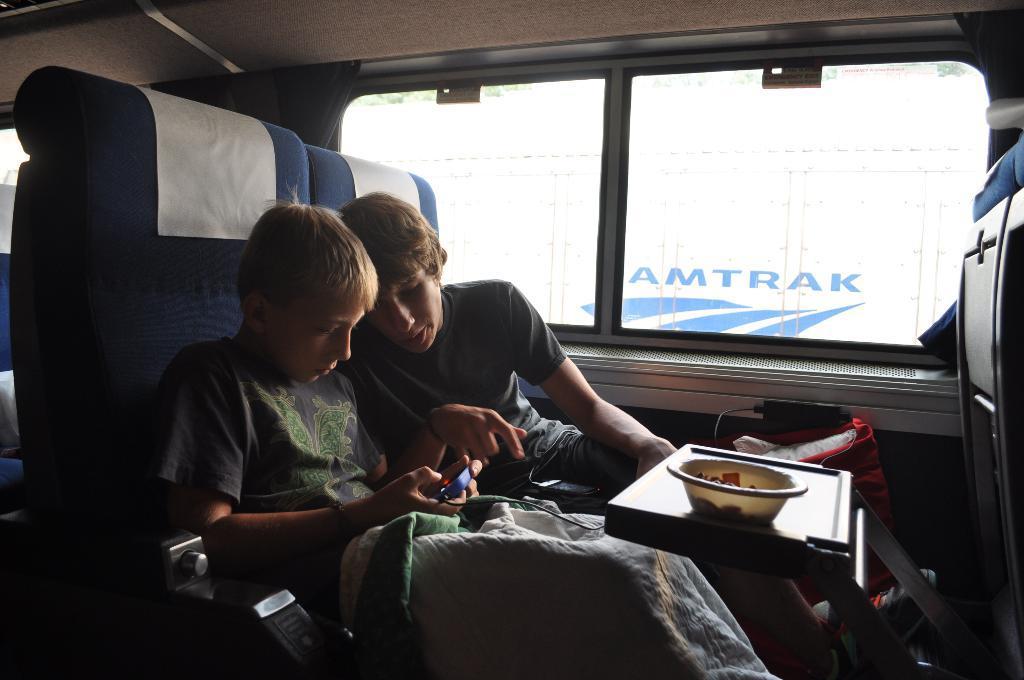How would you summarize this image in a sentence or two? In this picture I can see there are two people sitting in the seats and they are playing video game and there is a table in front of them and there is a bowl of food in it. There is a window and there is something visible from the window. 